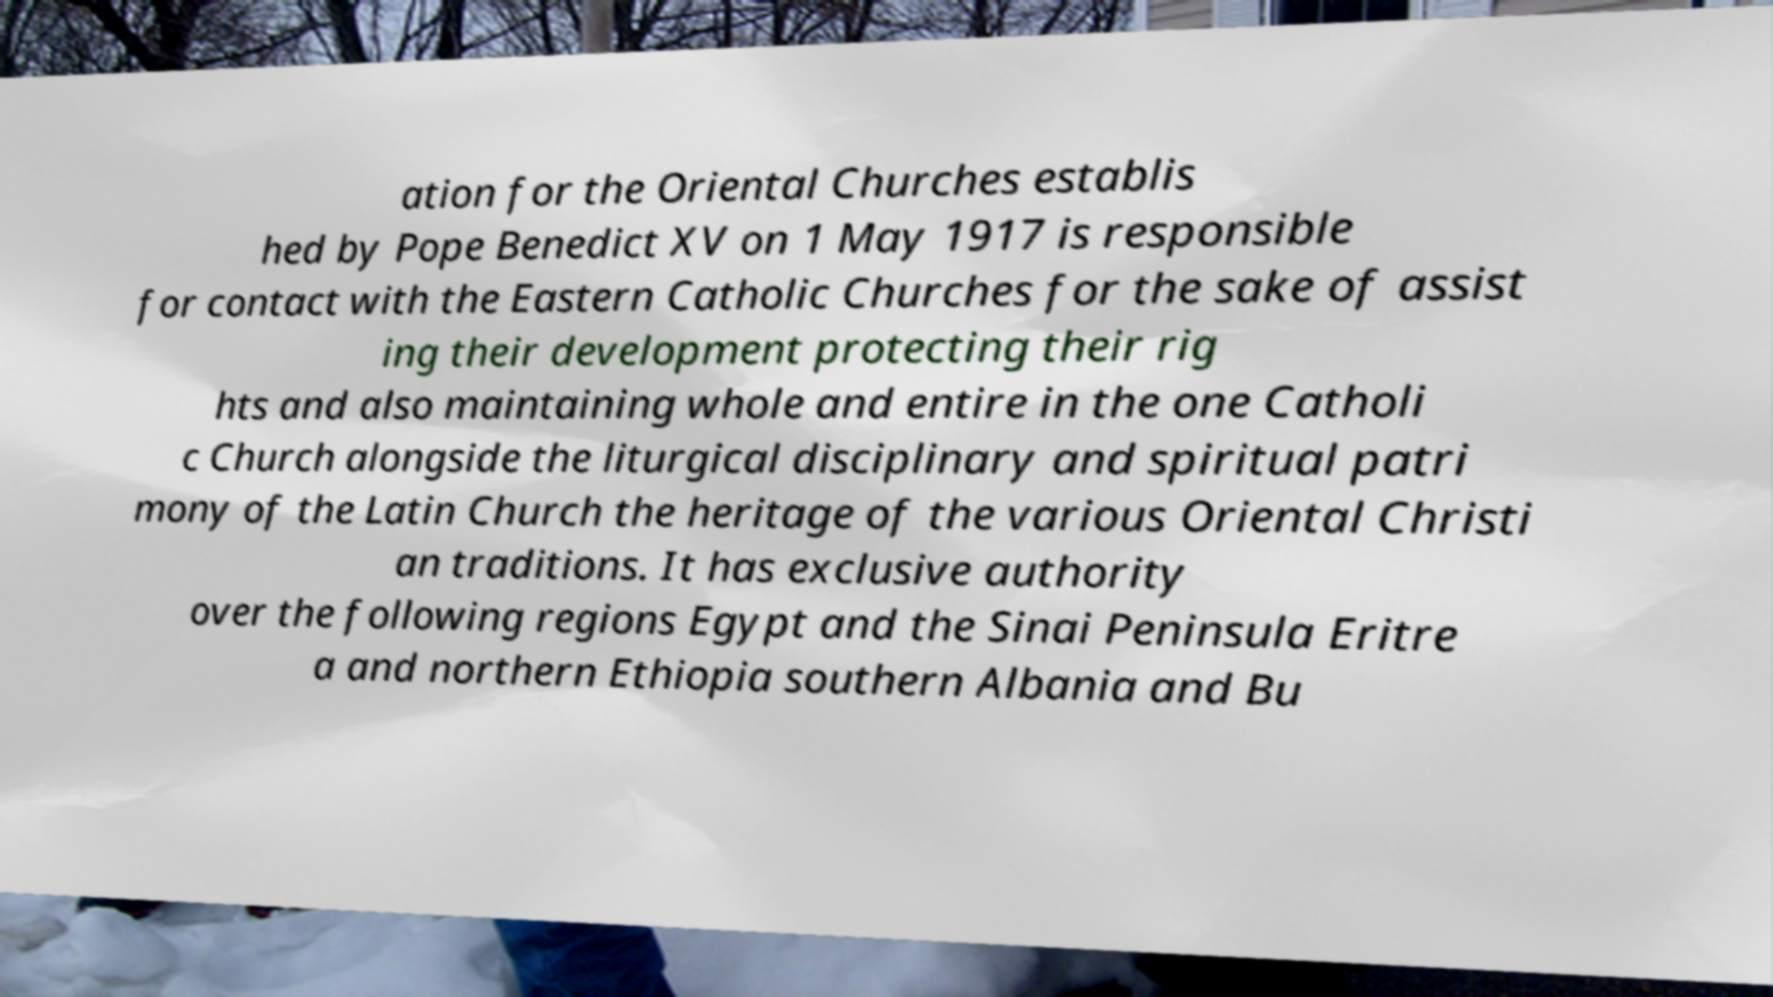Can you accurately transcribe the text from the provided image for me? ation for the Oriental Churches establis hed by Pope Benedict XV on 1 May 1917 is responsible for contact with the Eastern Catholic Churches for the sake of assist ing their development protecting their rig hts and also maintaining whole and entire in the one Catholi c Church alongside the liturgical disciplinary and spiritual patri mony of the Latin Church the heritage of the various Oriental Christi an traditions. It has exclusive authority over the following regions Egypt and the Sinai Peninsula Eritre a and northern Ethiopia southern Albania and Bu 